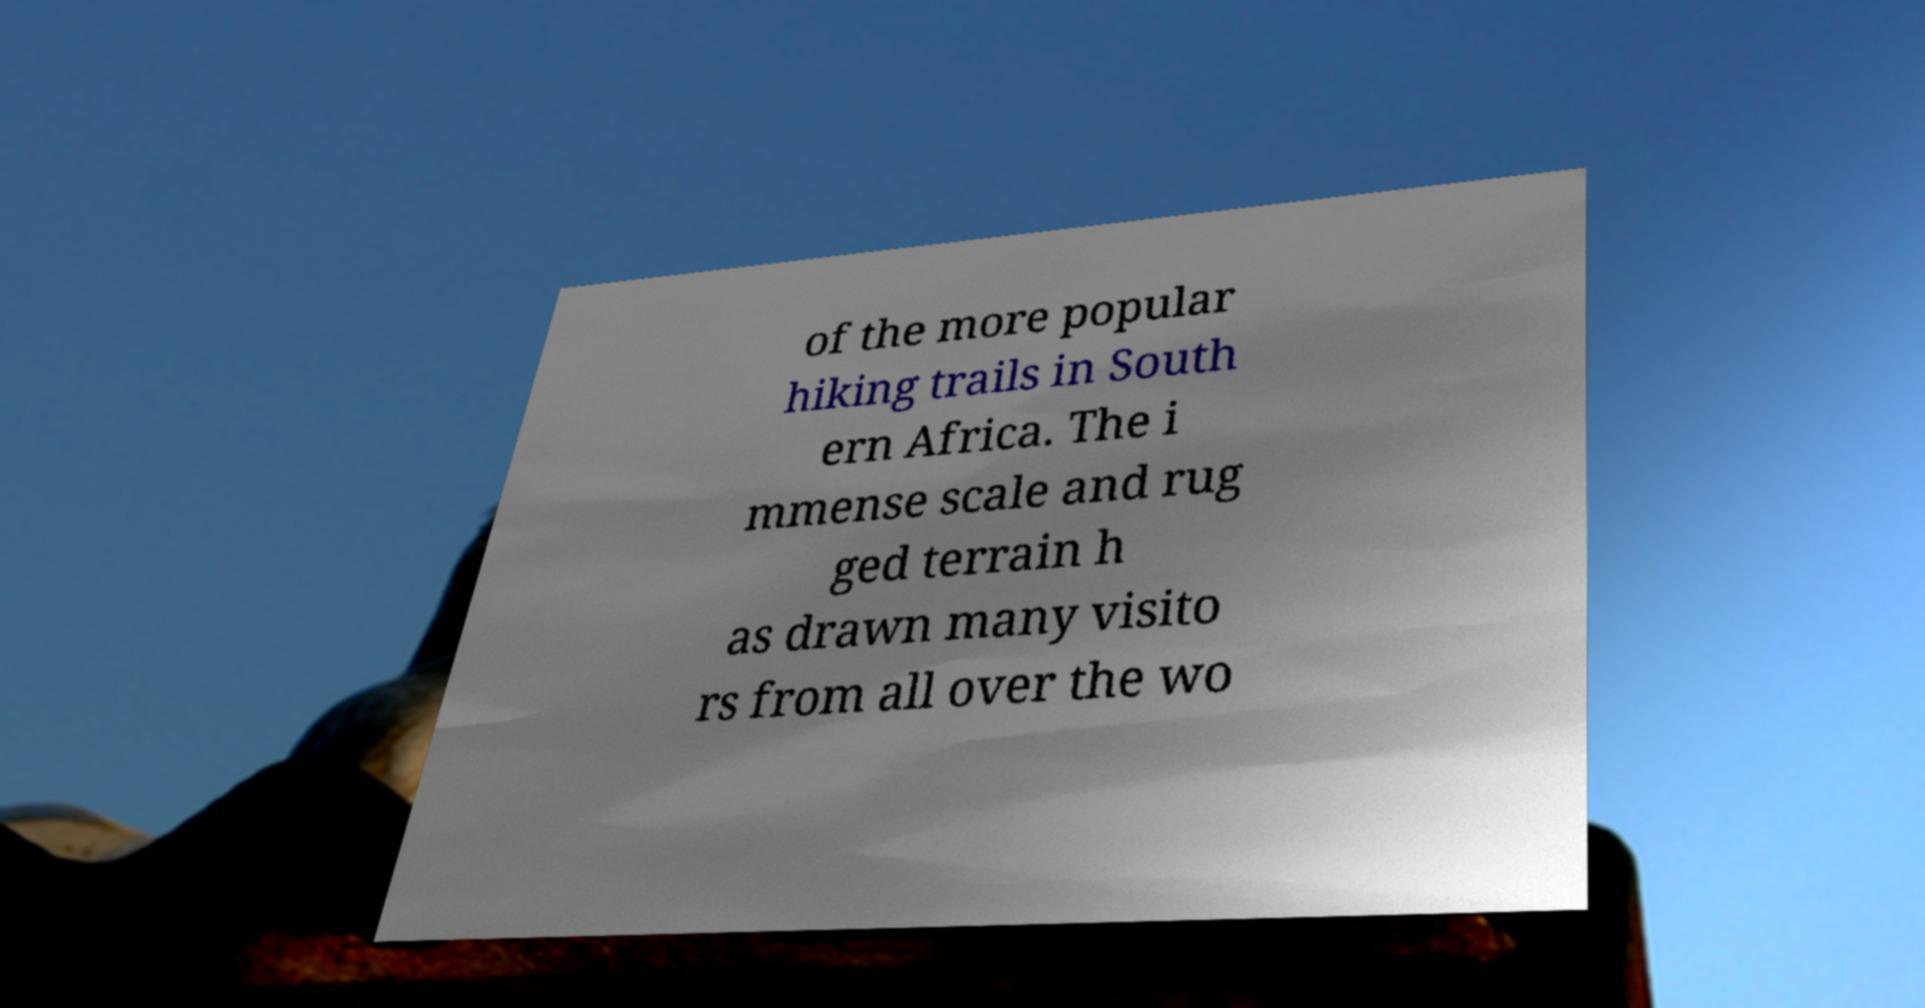There's text embedded in this image that I need extracted. Can you transcribe it verbatim? of the more popular hiking trails in South ern Africa. The i mmense scale and rug ged terrain h as drawn many visito rs from all over the wo 